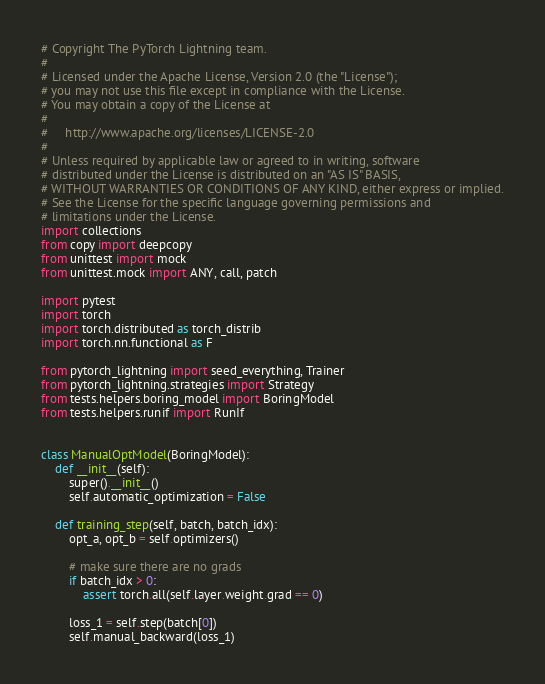<code> <loc_0><loc_0><loc_500><loc_500><_Python_># Copyright The PyTorch Lightning team.
#
# Licensed under the Apache License, Version 2.0 (the "License");
# you may not use this file except in compliance with the License.
# You may obtain a copy of the License at
#
#     http://www.apache.org/licenses/LICENSE-2.0
#
# Unless required by applicable law or agreed to in writing, software
# distributed under the License is distributed on an "AS IS" BASIS,
# WITHOUT WARRANTIES OR CONDITIONS OF ANY KIND, either express or implied.
# See the License for the specific language governing permissions and
# limitations under the License.
import collections
from copy import deepcopy
from unittest import mock
from unittest.mock import ANY, call, patch

import pytest
import torch
import torch.distributed as torch_distrib
import torch.nn.functional as F

from pytorch_lightning import seed_everything, Trainer
from pytorch_lightning.strategies import Strategy
from tests.helpers.boring_model import BoringModel
from tests.helpers.runif import RunIf


class ManualOptModel(BoringModel):
    def __init__(self):
        super().__init__()
        self.automatic_optimization = False

    def training_step(self, batch, batch_idx):
        opt_a, opt_b = self.optimizers()

        # make sure there are no grads
        if batch_idx > 0:
            assert torch.all(self.layer.weight.grad == 0)

        loss_1 = self.step(batch[0])
        self.manual_backward(loss_1)</code> 